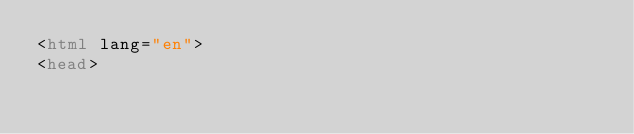<code> <loc_0><loc_0><loc_500><loc_500><_HTML_><html lang="en">
<head></code> 